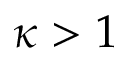Convert formula to latex. <formula><loc_0><loc_0><loc_500><loc_500>\kappa > 1</formula> 